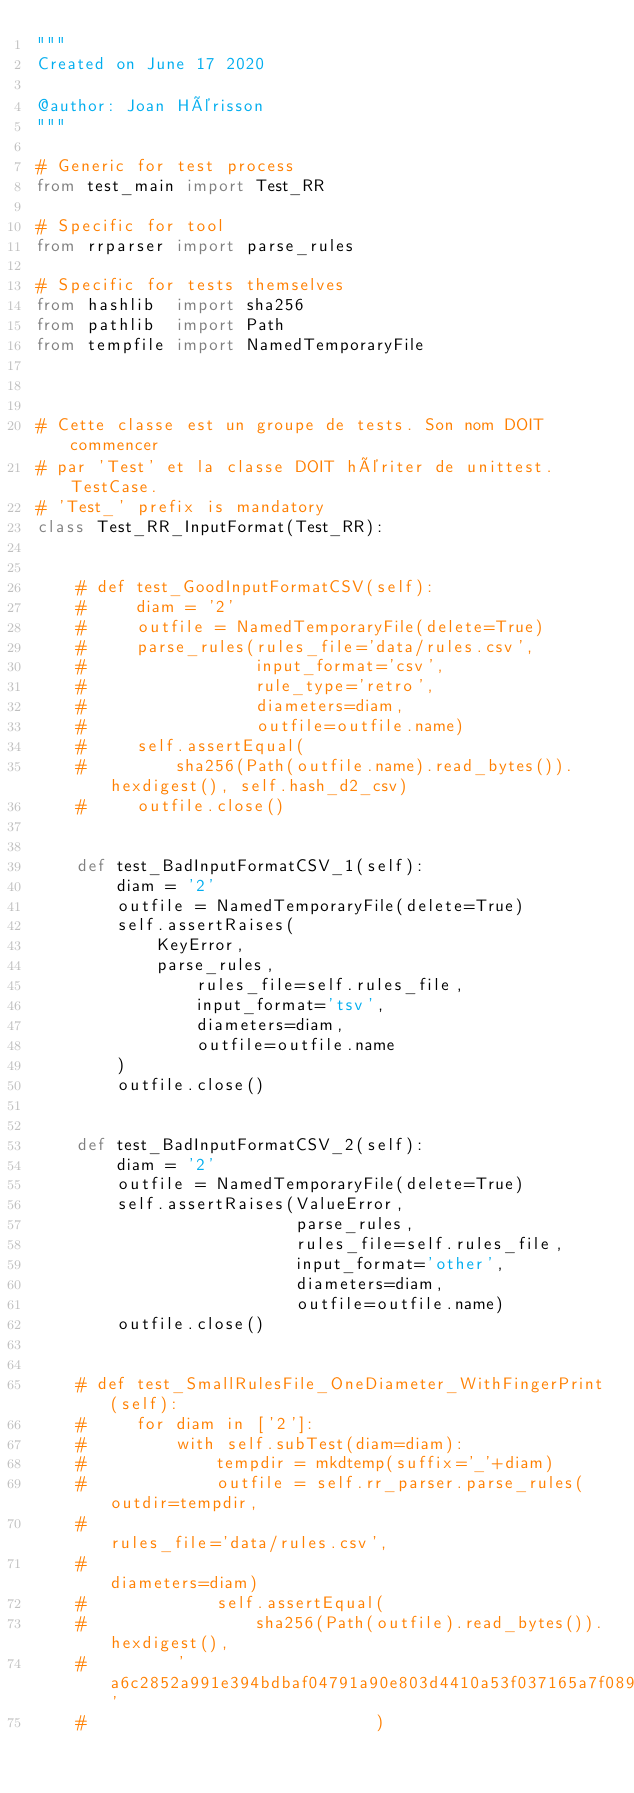Convert code to text. <code><loc_0><loc_0><loc_500><loc_500><_Python_>"""
Created on June 17 2020

@author: Joan Hérisson
"""

# Generic for test process
from test_main import Test_RR

# Specific for tool
from rrparser import parse_rules

# Specific for tests themselves
from hashlib  import sha256
from pathlib  import Path
from tempfile import NamedTemporaryFile



# Cette classe est un groupe de tests. Son nom DOIT commencer
# par 'Test' et la classe DOIT hériter de unittest.TestCase.
# 'Test_' prefix is mandatory
class Test_RR_InputFormat(Test_RR):


    # def test_GoodInputFormatCSV(self):
    #     diam = '2'
    #     outfile = NamedTemporaryFile(delete=True)
    #     parse_rules(rules_file='data/rules.csv',
    #                 input_format='csv',
    #                 rule_type='retro',
    #                 diameters=diam,
    #                 outfile=outfile.name)
    #     self.assertEqual(
    #         sha256(Path(outfile.name).read_bytes()).hexdigest(), self.hash_d2_csv)
    #     outfile.close()


    def test_BadInputFormatCSV_1(self):
        diam = '2'
        outfile = NamedTemporaryFile(delete=True)
        self.assertRaises(
            KeyError,
            parse_rules,
                rules_file=self.rules_file,
                input_format='tsv',
                diameters=diam,
                outfile=outfile.name
        )
        outfile.close()


    def test_BadInputFormatCSV_2(self):
        diam = '2'
        outfile = NamedTemporaryFile(delete=True)
        self.assertRaises(ValueError,
                          parse_rules,
                          rules_file=self.rules_file,
                          input_format='other',
                          diameters=diam,
                          outfile=outfile.name)
        outfile.close()


    # def test_SmallRulesFile_OneDiameter_WithFingerPrint(self):
    #     for diam in ['2']:
    #         with self.subTest(diam=diam):
    #             tempdir = mkdtemp(suffix='_'+diam)
    #             outfile = self.rr_parser.parse_rules(outdir=tempdir,
    #                                                  rules_file='data/rules.csv',
    #                                                  diameters=diam)
    #             self.assertEqual(
    #                 sha256(Path(outfile).read_bytes()).hexdigest(),
    #         'a6c2852a991e394bdbaf04791a90e803d4410a53f037165a7f08956edde63066'
    #                             )
</code> 